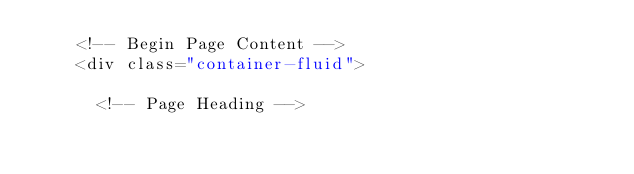Convert code to text. <code><loc_0><loc_0><loc_500><loc_500><_PHP_>    <!-- Begin Page Content -->
    <div class="container-fluid">

      <!-- Page Heading --></code> 